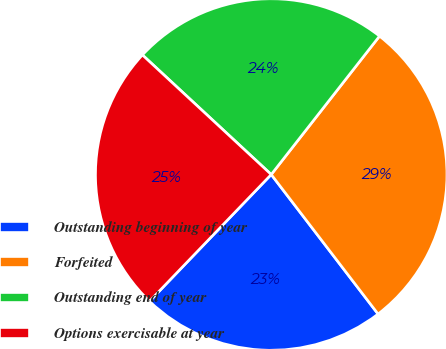Convert chart. <chart><loc_0><loc_0><loc_500><loc_500><pie_chart><fcel>Outstanding beginning of year<fcel>Forfeited<fcel>Outstanding end of year<fcel>Options exercisable at year<nl><fcel>22.58%<fcel>29.03%<fcel>23.66%<fcel>24.73%<nl></chart> 